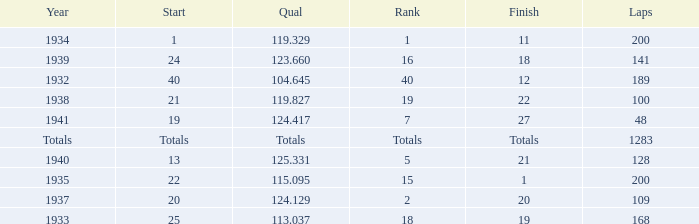What year did he start at 13? 1940.0. 